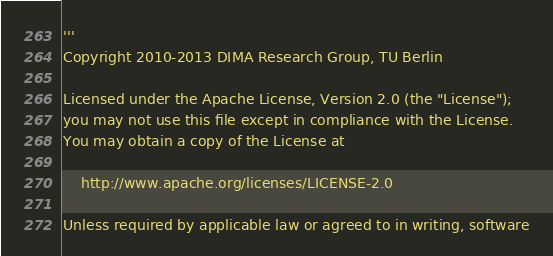Convert code to text. <code><loc_0><loc_0><loc_500><loc_500><_Python_>'''
Copyright 2010-2013 DIMA Research Group, TU Berlin

Licensed under the Apache License, Version 2.0 (the "License");
you may not use this file except in compliance with the License.
You may obtain a copy of the License at

    http://www.apache.org/licenses/LICENSE-2.0

Unless required by applicable law or agreed to in writing, software</code> 